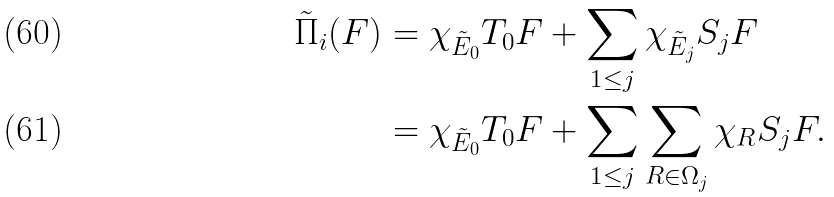<formula> <loc_0><loc_0><loc_500><loc_500>\tilde { \Pi } _ { i } ( F ) & = \chi _ { \tilde { E } _ { 0 } } T _ { 0 } F + \sum _ { 1 \leq j } \chi _ { \tilde { E } _ { j } } S _ { j } F \\ & = \chi _ { \tilde { E } _ { 0 } } T _ { 0 } F + \sum _ { 1 \leq j } \sum _ { R \in \Omega _ { j } } \chi _ { R } S _ { j } F .</formula> 